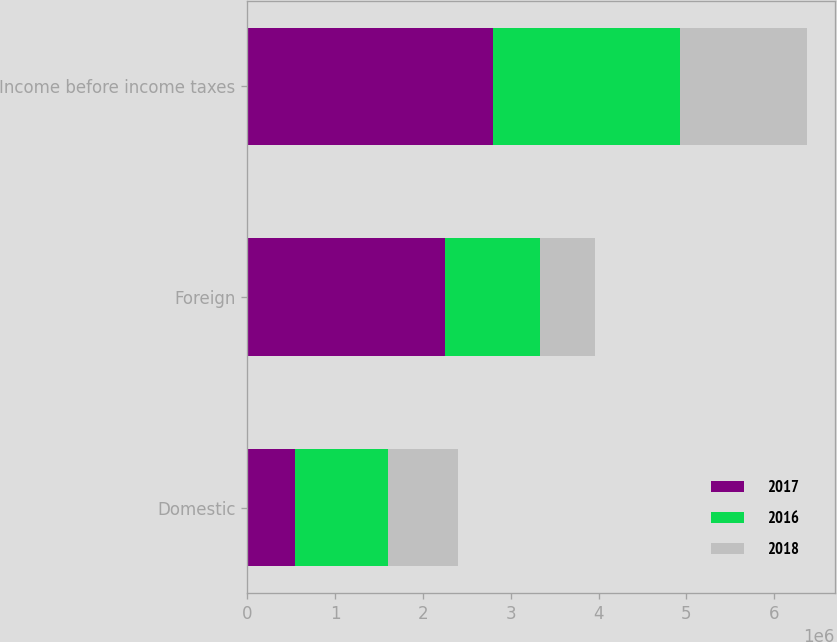Convert chart. <chart><loc_0><loc_0><loc_500><loc_500><stacked_bar_chart><ecel><fcel>Domestic<fcel>Foreign<fcel>Income before income taxes<nl><fcel>2017<fcel>542948<fcel>2.25093e+06<fcel>2.79388e+06<nl><fcel>2016<fcel>1.05616e+06<fcel>1.08148e+06<fcel>2.13764e+06<nl><fcel>2018<fcel>805749<fcel>629389<fcel>1.43514e+06<nl></chart> 